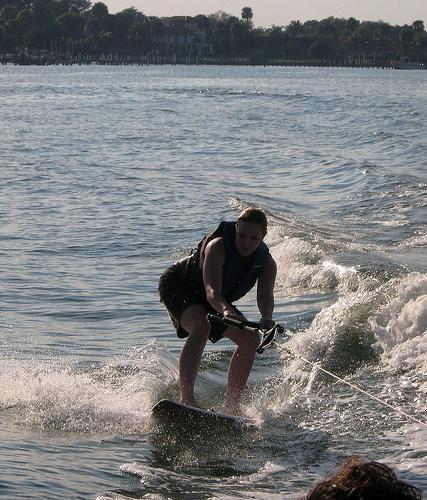How many women are there?
Give a very brief answer. 1. 